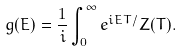<formula> <loc_0><loc_0><loc_500><loc_500>g ( E ) = \frac { 1 } { i } \int _ { 0 } ^ { \infty } e ^ { i E T / } Z ( T ) .</formula> 